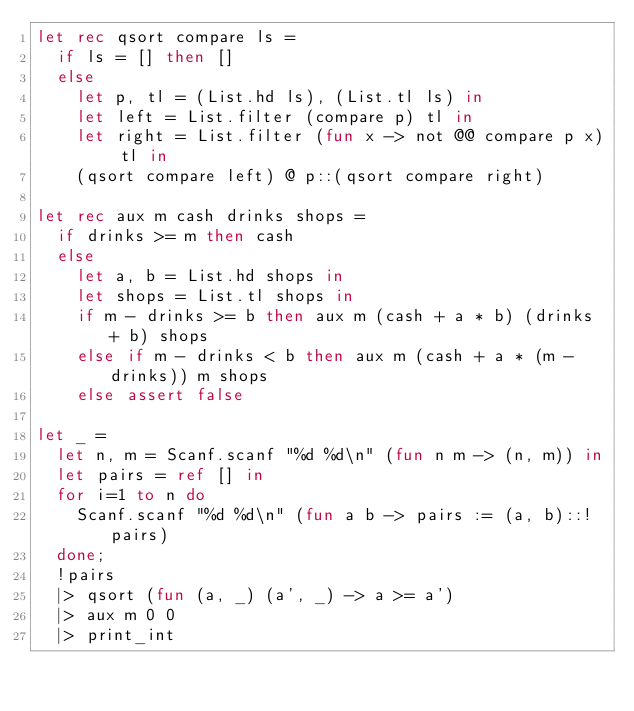Convert code to text. <code><loc_0><loc_0><loc_500><loc_500><_OCaml_>let rec qsort compare ls =
  if ls = [] then []
  else
    let p, tl = (List.hd ls), (List.tl ls) in
    let left = List.filter (compare p) tl in
    let right = List.filter (fun x -> not @@ compare p x) tl in
    (qsort compare left) @ p::(qsort compare right)

let rec aux m cash drinks shops =
  if drinks >= m then cash
  else
    let a, b = List.hd shops in
    let shops = List.tl shops in
    if m - drinks >= b then aux m (cash + a * b) (drinks + b) shops
    else if m - drinks < b then aux m (cash + a * (m - drinks)) m shops
    else assert false 

let _ =
  let n, m = Scanf.scanf "%d %d\n" (fun n m -> (n, m)) in
  let pairs = ref [] in
  for i=1 to n do
    Scanf.scanf "%d %d\n" (fun a b -> pairs := (a, b)::!pairs)
  done;
  !pairs
  |> qsort (fun (a, _) (a', _) -> a >= a')
  |> aux m 0 0
  |> print_int</code> 